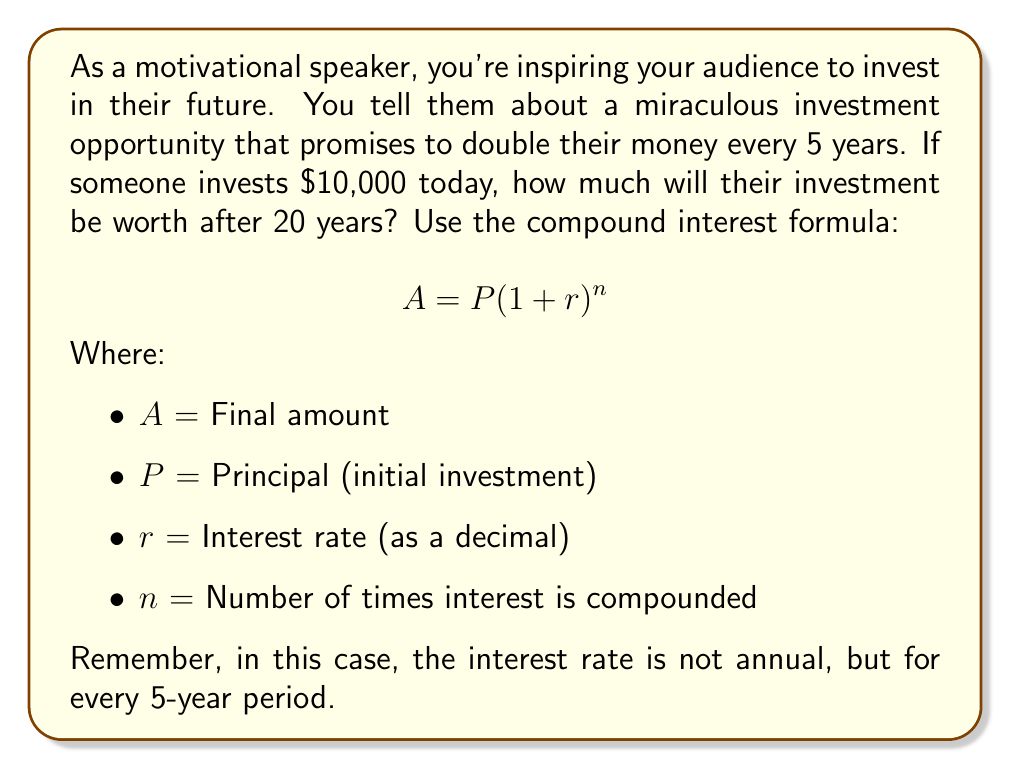Can you solve this math problem? Let's break this down step-by-step:

1) First, we need to identify our variables:
   P = $10,000 (initial investment)
   r = 100% = 1 (the investment doubles, so it grows by 100%)
   n = 4 (20 years divided by 5-year periods = 4 compounding periods)

2) Now, let's plug these into our compound interest formula:

   $$ A = P(1 + r)^n $$
   $$ A = 10000(1 + 1)^4 $$

3) Simplify inside the parentheses:
   $$ A = 10000(2)^4 $$

4) Calculate the exponent:
   $$ A = 10000 * 16 $$

5) Multiply:
   $$ A = 160000 $$

Therefore, after 20 years, the investment would be worth $160,000.

This example demonstrates the power of compound interest over time, which is often used in motivational speaking to encourage long-term financial planning and investment.
Answer: $160,000 